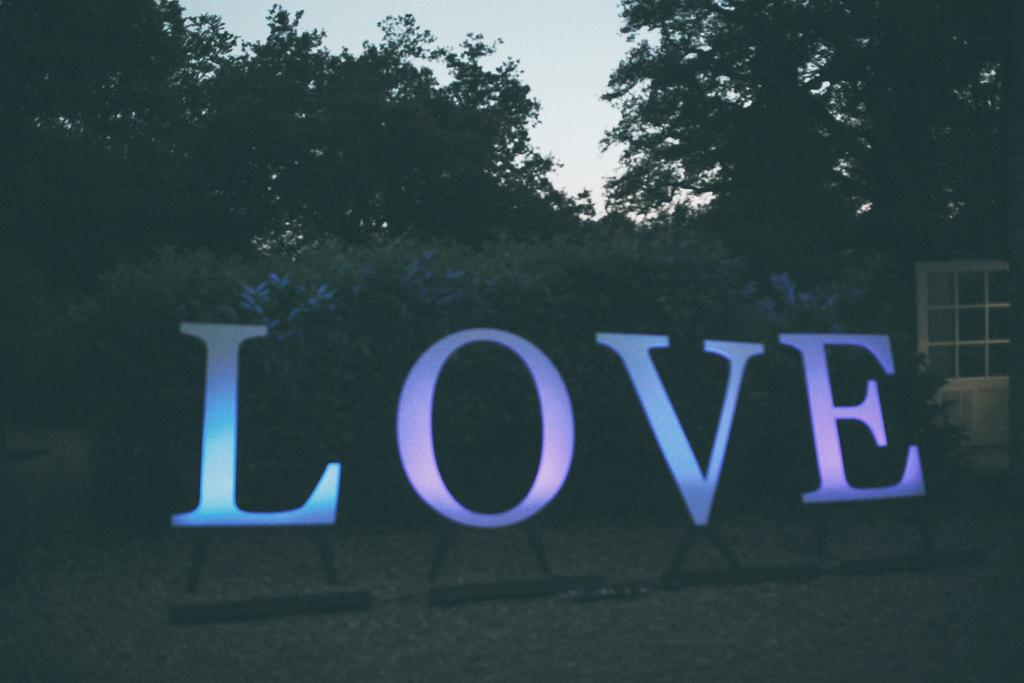What objects are present in the image that are used for displaying letters? There are letter stands in the image. What type of natural scenery can be seen in the background of the image? There are trees in the background of the image. What feature of a building can be seen in the image? There is a door visible in the image. What is visible at the top of the image? The sky is visible at the top of the image. How many feet are visible in the image? There are no feet visible in the image. What type of seat can be seen in the image? There is no seat present in the image. 